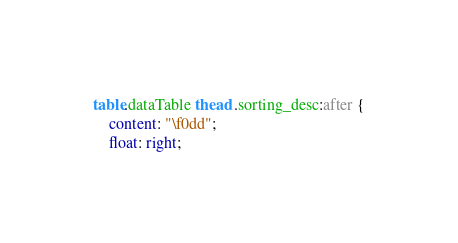<code> <loc_0><loc_0><loc_500><loc_500><_CSS_>table.dataTable thead .sorting_desc:after {
    content: "\f0dd";
    float: right;</code> 